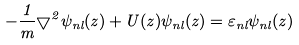Convert formula to latex. <formula><loc_0><loc_0><loc_500><loc_500>- \frac { 1 } { m } { \bigtriangledown } ^ { 2 } { \psi } _ { n l } ( { z } ) + U ( { z } ) { \psi } _ { n l } ( { z } ) = { \varepsilon } _ { n l } { \psi } _ { n l } ( { z } )</formula> 